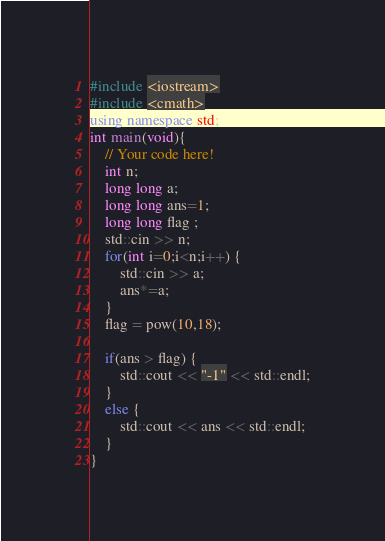<code> <loc_0><loc_0><loc_500><loc_500><_C++_>#include <iostream>
#include <cmath>
using namespace std;
int main(void){
    // Your code here!
    int n;
    long long a;
    long long ans=1;
    long long flag ;
    std::cin >> n;
    for(int i=0;i<n;i++) {
        std::cin >> a;
        ans*=a;
    }
    flag = pow(10,18);

    if(ans > flag) {
        std::cout << "-1" << std::endl;
    }
    else {
        std::cout << ans << std::endl;
    }
}
</code> 